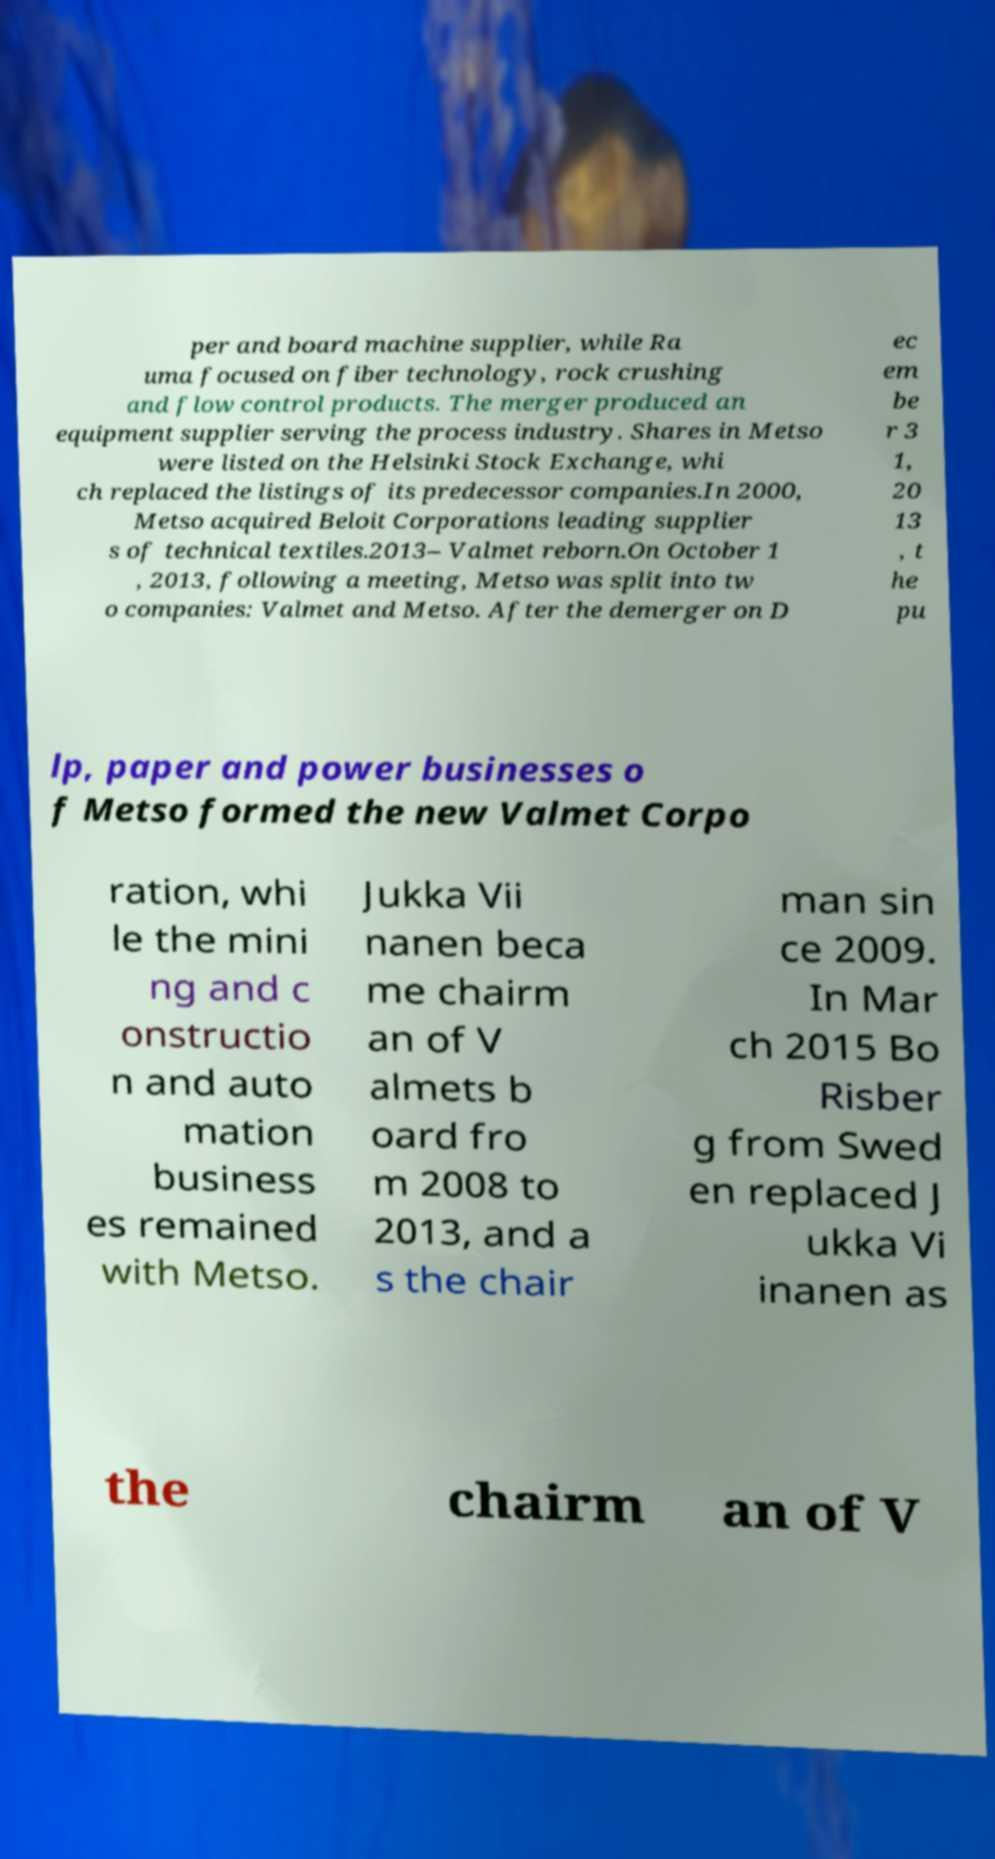Can you accurately transcribe the text from the provided image for me? per and board machine supplier, while Ra uma focused on fiber technology, rock crushing and flow control products. The merger produced an equipment supplier serving the process industry. Shares in Metso were listed on the Helsinki Stock Exchange, whi ch replaced the listings of its predecessor companies.In 2000, Metso acquired Beloit Corporations leading supplier s of technical textiles.2013– Valmet reborn.On October 1 , 2013, following a meeting, Metso was split into tw o companies: Valmet and Metso. After the demerger on D ec em be r 3 1, 20 13 , t he pu lp, paper and power businesses o f Metso formed the new Valmet Corpo ration, whi le the mini ng and c onstructio n and auto mation business es remained with Metso. Jukka Vii nanen beca me chairm an of V almets b oard fro m 2008 to 2013, and a s the chair man sin ce 2009. In Mar ch 2015 Bo Risber g from Swed en replaced J ukka Vi inanen as the chairm an of V 